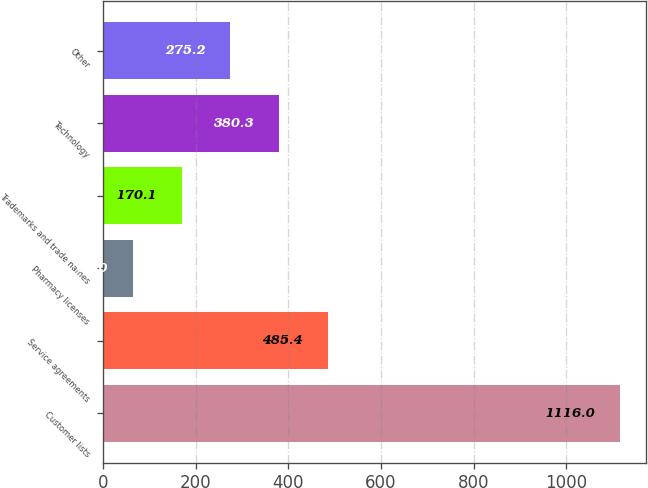<chart> <loc_0><loc_0><loc_500><loc_500><bar_chart><fcel>Customer lists<fcel>Service agreements<fcel>Pharmacy licenses<fcel>Trademarks and trade names<fcel>Technology<fcel>Other<nl><fcel>1116<fcel>485.4<fcel>65<fcel>170.1<fcel>380.3<fcel>275.2<nl></chart> 